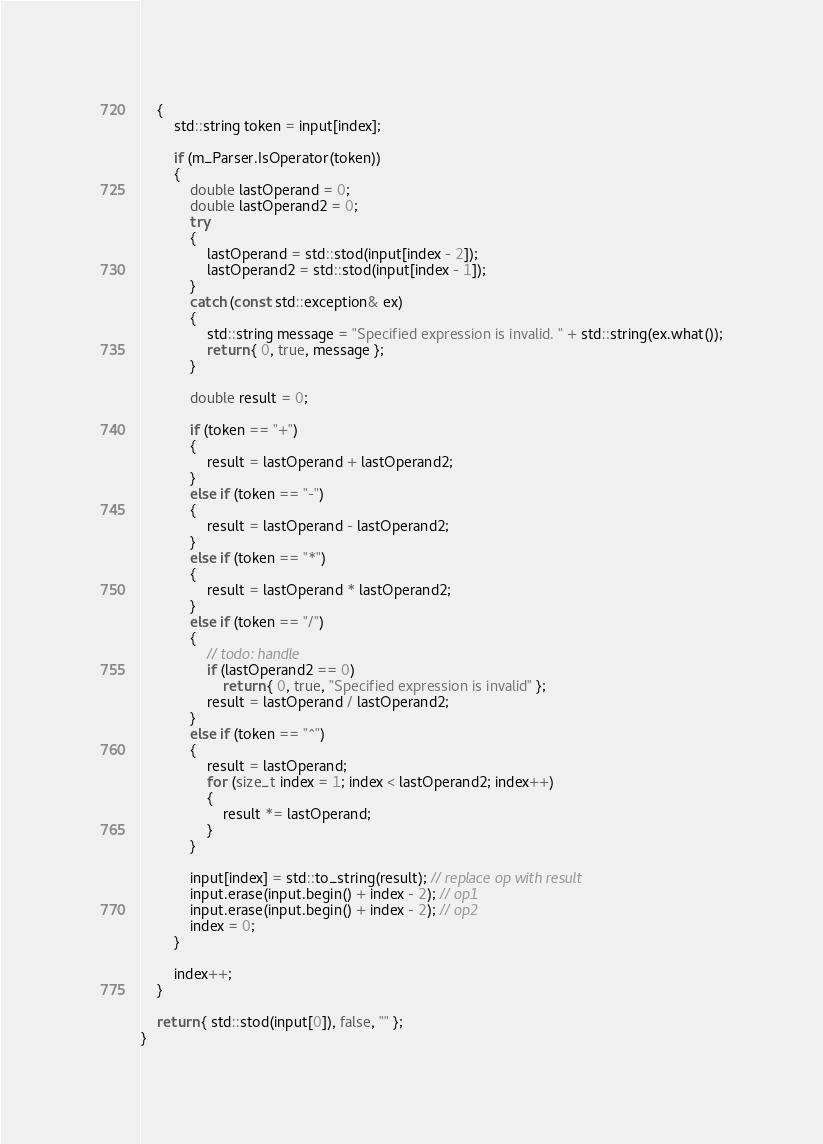<code> <loc_0><loc_0><loc_500><loc_500><_C++_>	{
		std::string token = input[index];

		if (m_Parser.IsOperator(token))
		{
			double lastOperand = 0;
			double lastOperand2 = 0;
			try
			{
				lastOperand = std::stod(input[index - 2]);
				lastOperand2 = std::stod(input[index - 1]);
			}
			catch (const std::exception& ex)
			{
				std::string message = "Specified expression is invalid. " + std::string(ex.what());
				return { 0, true, message };
			}

			double result = 0;

			if (token == "+")
			{
				result = lastOperand + lastOperand2;
			}
			else if (token == "-")
			{
				result = lastOperand - lastOperand2;
			}
			else if (token == "*")
			{
				result = lastOperand * lastOperand2;
			}
			else if (token == "/")
			{
				// todo: handle
				if (lastOperand2 == 0)
					return { 0, true, "Specified expression is invalid" };
				result = lastOperand / lastOperand2;
			}
			else if (token == "^")
			{
				result = lastOperand;
				for (size_t index = 1; index < lastOperand2; index++)
				{
					result *= lastOperand;
				}
			}

			input[index] = std::to_string(result); // replace op with result
			input.erase(input.begin() + index - 2); // op1
			input.erase(input.begin() + index - 2); // op2
			index = 0;
		}

		index++;
	}

	return { std::stod(input[0]), false, "" };
}</code> 